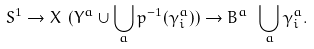<formula> <loc_0><loc_0><loc_500><loc_500>S ^ { 1 } \to X \ ( Y ^ { a } \cup \bigcup _ { a } p ^ { - 1 } ( \gamma ^ { a } _ { i } ) ) \to B ^ { a } \ \bigcup _ { a } \gamma ^ { a } _ { i } .</formula> 